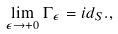Convert formula to latex. <formula><loc_0><loc_0><loc_500><loc_500>\lim _ { \epsilon \rightarrow + 0 } \Gamma _ { \epsilon } = i d _ { S } . ,</formula> 